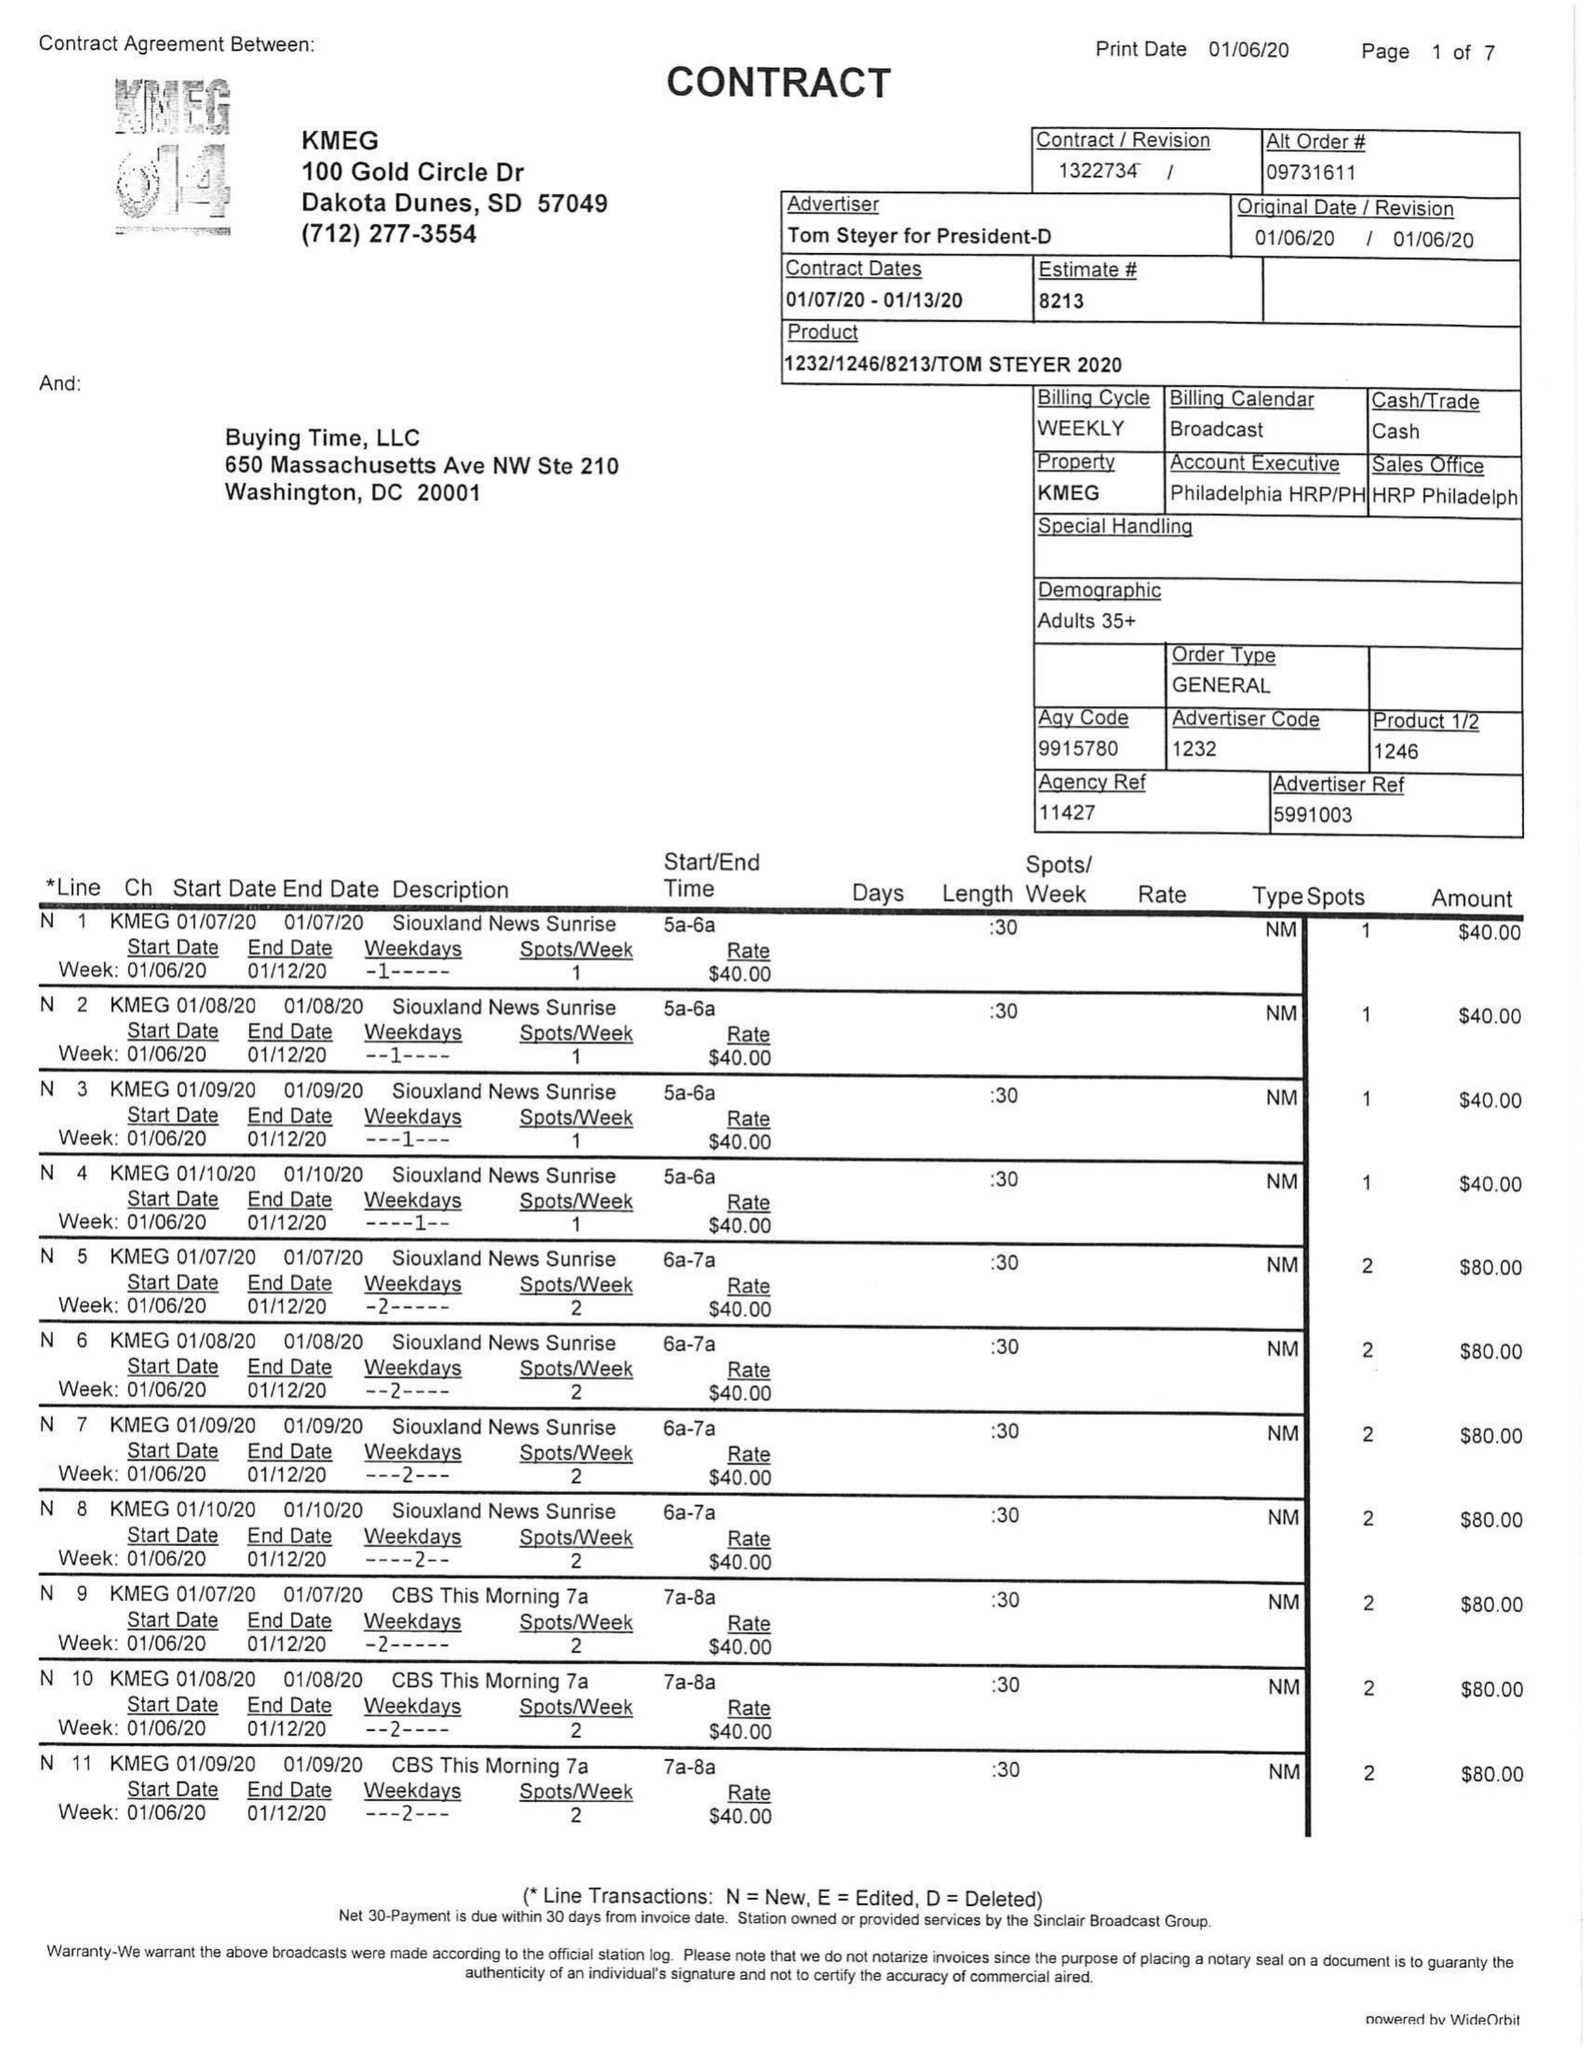What is the value for the contract_num?
Answer the question using a single word or phrase. 1322734 